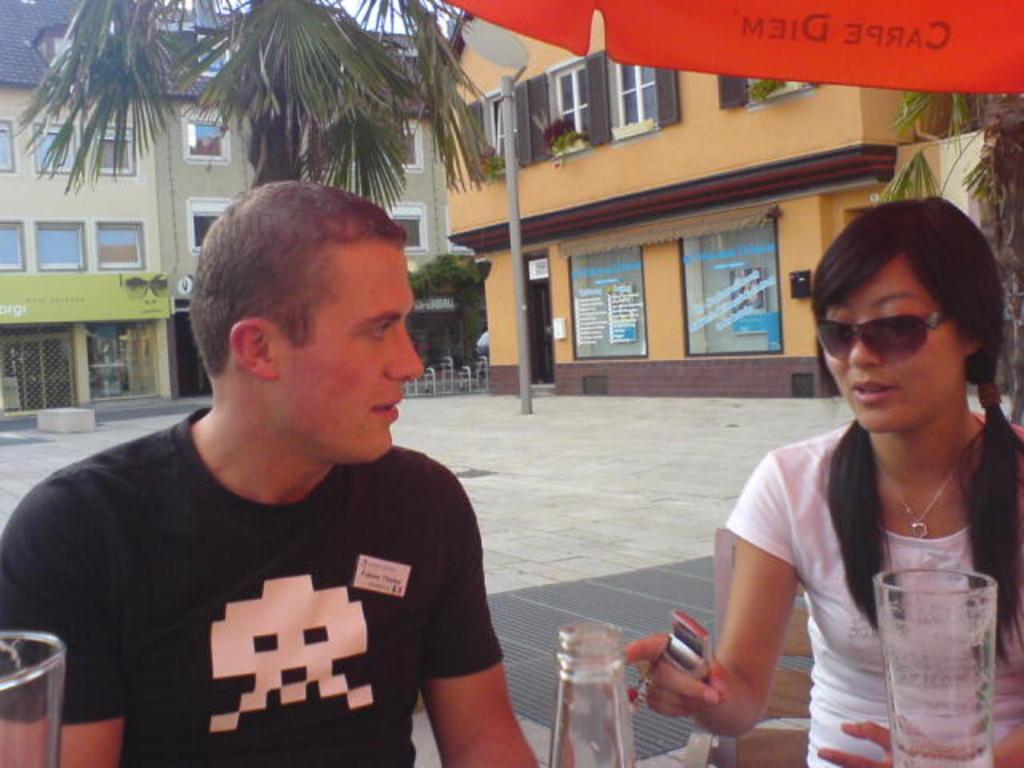How would you summarize this image in a sentence or two? This picture is clicked outside a city. In the foreground of the picture there is a woman in white dress seated. To the left there is a man in black t-shirt seated. In the background there are buildings. To the top right there is a palm tree. In the center of the background the palm tree. In the center there is a pole. Sky is visible. On the top right there is a red color umbrella. 